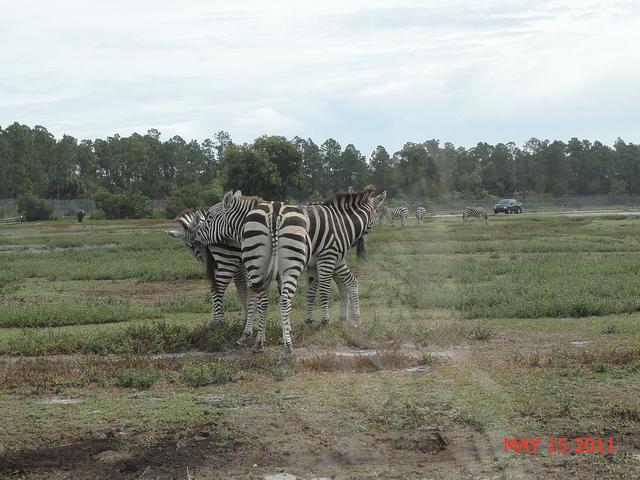How many zebras are in the photo?
Answer briefly. 2. What animal is this?
Be succinct. Zebra. Are these animals likely in a zoo?
Give a very brief answer. Yes. What date was this photo taken?
Be succinct. May 15, 2011. What colors are the animals?
Give a very brief answer. Black and white. 